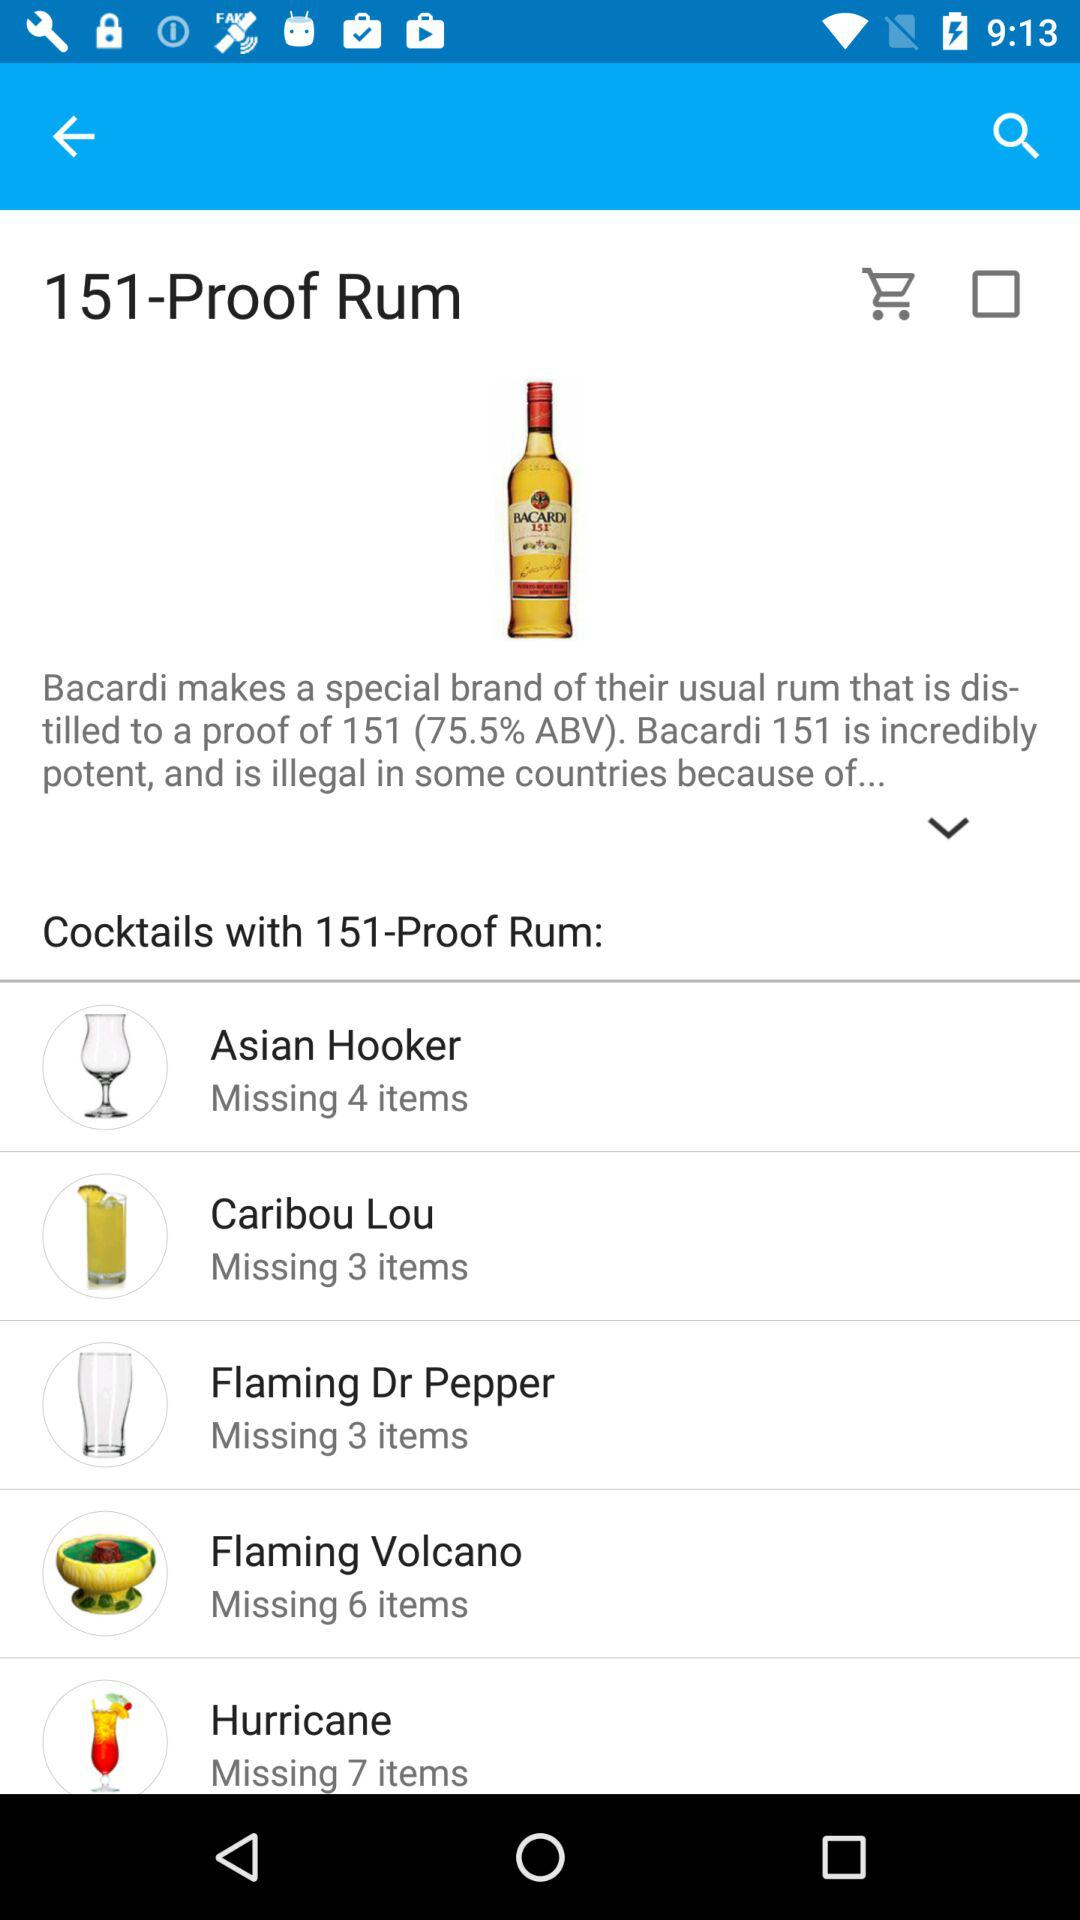What is the count of missing items in Hurricane? The count of missing items in Hurricane is 7. 